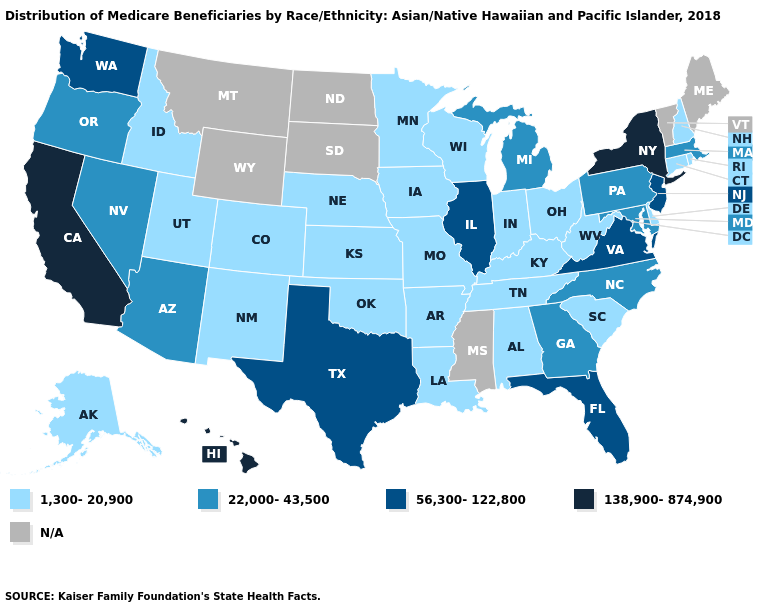Name the states that have a value in the range 1,300-20,900?
Keep it brief. Alabama, Alaska, Arkansas, Colorado, Connecticut, Delaware, Idaho, Indiana, Iowa, Kansas, Kentucky, Louisiana, Minnesota, Missouri, Nebraska, New Hampshire, New Mexico, Ohio, Oklahoma, Rhode Island, South Carolina, Tennessee, Utah, West Virginia, Wisconsin. Name the states that have a value in the range 1,300-20,900?
Give a very brief answer. Alabama, Alaska, Arkansas, Colorado, Connecticut, Delaware, Idaho, Indiana, Iowa, Kansas, Kentucky, Louisiana, Minnesota, Missouri, Nebraska, New Hampshire, New Mexico, Ohio, Oklahoma, Rhode Island, South Carolina, Tennessee, Utah, West Virginia, Wisconsin. Does Pennsylvania have the highest value in the Northeast?
Quick response, please. No. Which states hav the highest value in the Northeast?
Quick response, please. New York. What is the lowest value in states that border Montana?
Give a very brief answer. 1,300-20,900. Does Virginia have the highest value in the USA?
Short answer required. No. Is the legend a continuous bar?
Give a very brief answer. No. What is the value of Oregon?
Answer briefly. 22,000-43,500. Name the states that have a value in the range 138,900-874,900?
Write a very short answer. California, Hawaii, New York. Does New Hampshire have the highest value in the Northeast?
Short answer required. No. What is the value of Vermont?
Write a very short answer. N/A. What is the value of South Carolina?
Quick response, please. 1,300-20,900. Among the states that border West Virginia , does Ohio have the lowest value?
Concise answer only. Yes. 